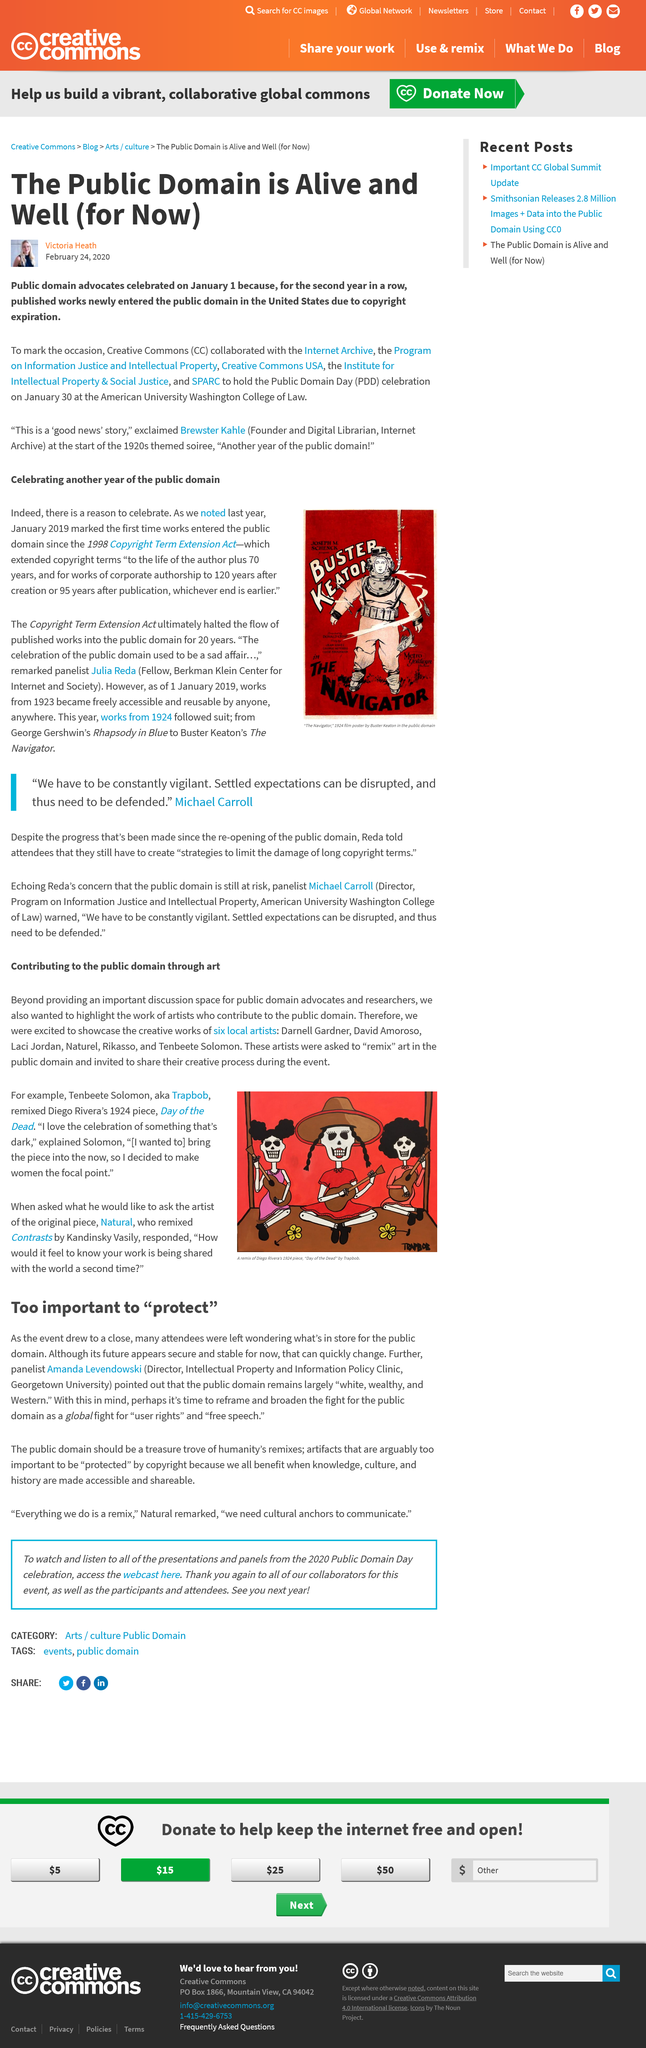Draw attention to some important aspects in this diagram. The Buster Keaton film poster displayed is from the year 1924. As of 1 January 2019, works from the year 1923 became freely accessible. The article is about public domain, which refers to a category of intellectual property rights that allows for the free use and distribution of an idea or work without restrictions or permissions from the original creator or owner. We obtained the Copyright Term Extension Act in the year 1998. The name of the Director of the Intellectual Property and Information Policy Clinic at Georgetown University is Amanda Levendowski. 